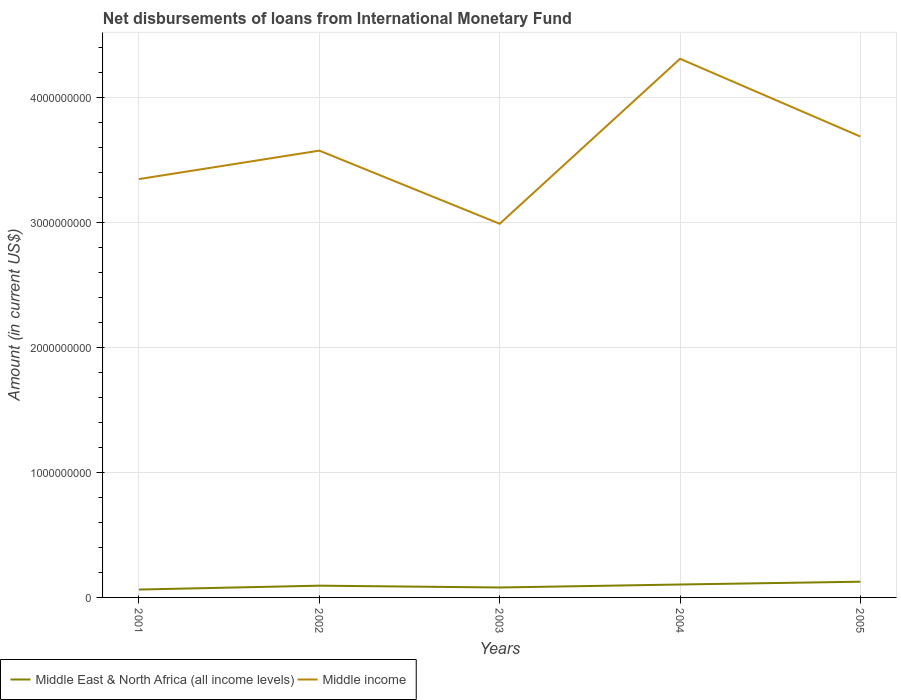How many different coloured lines are there?
Offer a terse response. 2. Across all years, what is the maximum amount of loans disbursed in Middle East & North Africa (all income levels)?
Offer a very short reply. 6.31e+07. What is the total amount of loans disbursed in Middle East & North Africa (all income levels) in the graph?
Keep it short and to the point. -2.40e+07. What is the difference between the highest and the second highest amount of loans disbursed in Middle income?
Offer a terse response. 1.32e+09. Is the amount of loans disbursed in Middle East & North Africa (all income levels) strictly greater than the amount of loans disbursed in Middle income over the years?
Your answer should be compact. Yes. How many lines are there?
Provide a short and direct response. 2. How many years are there in the graph?
Ensure brevity in your answer.  5. What is the difference between two consecutive major ticks on the Y-axis?
Offer a terse response. 1.00e+09. Does the graph contain any zero values?
Provide a short and direct response. No. Does the graph contain grids?
Provide a succinct answer. Yes. Where does the legend appear in the graph?
Provide a succinct answer. Bottom left. How many legend labels are there?
Provide a succinct answer. 2. What is the title of the graph?
Your answer should be compact. Net disbursements of loans from International Monetary Fund. Does "United Arab Emirates" appear as one of the legend labels in the graph?
Provide a succinct answer. No. What is the label or title of the X-axis?
Offer a terse response. Years. What is the label or title of the Y-axis?
Provide a succinct answer. Amount (in current US$). What is the Amount (in current US$) in Middle East & North Africa (all income levels) in 2001?
Your response must be concise. 6.31e+07. What is the Amount (in current US$) of Middle income in 2001?
Your response must be concise. 3.35e+09. What is the Amount (in current US$) in Middle East & North Africa (all income levels) in 2002?
Your response must be concise. 9.41e+07. What is the Amount (in current US$) in Middle income in 2002?
Your answer should be compact. 3.58e+09. What is the Amount (in current US$) of Middle East & North Africa (all income levels) in 2003?
Make the answer very short. 7.96e+07. What is the Amount (in current US$) of Middle income in 2003?
Give a very brief answer. 2.99e+09. What is the Amount (in current US$) of Middle East & North Africa (all income levels) in 2004?
Provide a succinct answer. 1.04e+08. What is the Amount (in current US$) in Middle income in 2004?
Ensure brevity in your answer.  4.31e+09. What is the Amount (in current US$) in Middle East & North Africa (all income levels) in 2005?
Your response must be concise. 1.26e+08. What is the Amount (in current US$) in Middle income in 2005?
Give a very brief answer. 3.69e+09. Across all years, what is the maximum Amount (in current US$) of Middle East & North Africa (all income levels)?
Ensure brevity in your answer.  1.26e+08. Across all years, what is the maximum Amount (in current US$) in Middle income?
Provide a short and direct response. 4.31e+09. Across all years, what is the minimum Amount (in current US$) in Middle East & North Africa (all income levels)?
Offer a very short reply. 6.31e+07. Across all years, what is the minimum Amount (in current US$) of Middle income?
Give a very brief answer. 2.99e+09. What is the total Amount (in current US$) in Middle East & North Africa (all income levels) in the graph?
Offer a very short reply. 4.66e+08. What is the total Amount (in current US$) in Middle income in the graph?
Provide a short and direct response. 1.79e+1. What is the difference between the Amount (in current US$) of Middle East & North Africa (all income levels) in 2001 and that in 2002?
Give a very brief answer. -3.10e+07. What is the difference between the Amount (in current US$) of Middle income in 2001 and that in 2002?
Offer a terse response. -2.28e+08. What is the difference between the Amount (in current US$) in Middle East & North Africa (all income levels) in 2001 and that in 2003?
Give a very brief answer. -1.65e+07. What is the difference between the Amount (in current US$) of Middle income in 2001 and that in 2003?
Give a very brief answer. 3.58e+08. What is the difference between the Amount (in current US$) of Middle East & North Africa (all income levels) in 2001 and that in 2004?
Give a very brief answer. -4.04e+07. What is the difference between the Amount (in current US$) in Middle income in 2001 and that in 2004?
Make the answer very short. -9.63e+08. What is the difference between the Amount (in current US$) in Middle East & North Africa (all income levels) in 2001 and that in 2005?
Give a very brief answer. -6.28e+07. What is the difference between the Amount (in current US$) in Middle income in 2001 and that in 2005?
Offer a terse response. -3.40e+08. What is the difference between the Amount (in current US$) of Middle East & North Africa (all income levels) in 2002 and that in 2003?
Ensure brevity in your answer.  1.46e+07. What is the difference between the Amount (in current US$) in Middle income in 2002 and that in 2003?
Keep it short and to the point. 5.86e+08. What is the difference between the Amount (in current US$) in Middle East & North Africa (all income levels) in 2002 and that in 2004?
Offer a terse response. -9.41e+06. What is the difference between the Amount (in current US$) in Middle income in 2002 and that in 2004?
Offer a terse response. -7.35e+08. What is the difference between the Amount (in current US$) in Middle East & North Africa (all income levels) in 2002 and that in 2005?
Provide a succinct answer. -3.17e+07. What is the difference between the Amount (in current US$) of Middle income in 2002 and that in 2005?
Give a very brief answer. -1.13e+08. What is the difference between the Amount (in current US$) in Middle East & North Africa (all income levels) in 2003 and that in 2004?
Provide a succinct answer. -2.40e+07. What is the difference between the Amount (in current US$) in Middle income in 2003 and that in 2004?
Your answer should be very brief. -1.32e+09. What is the difference between the Amount (in current US$) of Middle East & North Africa (all income levels) in 2003 and that in 2005?
Provide a succinct answer. -4.63e+07. What is the difference between the Amount (in current US$) in Middle income in 2003 and that in 2005?
Offer a very short reply. -6.98e+08. What is the difference between the Amount (in current US$) of Middle East & North Africa (all income levels) in 2004 and that in 2005?
Keep it short and to the point. -2.23e+07. What is the difference between the Amount (in current US$) of Middle income in 2004 and that in 2005?
Offer a terse response. 6.23e+08. What is the difference between the Amount (in current US$) of Middle East & North Africa (all income levels) in 2001 and the Amount (in current US$) of Middle income in 2002?
Your response must be concise. -3.51e+09. What is the difference between the Amount (in current US$) in Middle East & North Africa (all income levels) in 2001 and the Amount (in current US$) in Middle income in 2003?
Ensure brevity in your answer.  -2.93e+09. What is the difference between the Amount (in current US$) of Middle East & North Africa (all income levels) in 2001 and the Amount (in current US$) of Middle income in 2004?
Offer a very short reply. -4.25e+09. What is the difference between the Amount (in current US$) in Middle East & North Africa (all income levels) in 2001 and the Amount (in current US$) in Middle income in 2005?
Offer a very short reply. -3.63e+09. What is the difference between the Amount (in current US$) in Middle East & North Africa (all income levels) in 2002 and the Amount (in current US$) in Middle income in 2003?
Provide a short and direct response. -2.90e+09. What is the difference between the Amount (in current US$) of Middle East & North Africa (all income levels) in 2002 and the Amount (in current US$) of Middle income in 2004?
Give a very brief answer. -4.22e+09. What is the difference between the Amount (in current US$) of Middle East & North Africa (all income levels) in 2002 and the Amount (in current US$) of Middle income in 2005?
Offer a very short reply. -3.60e+09. What is the difference between the Amount (in current US$) of Middle East & North Africa (all income levels) in 2003 and the Amount (in current US$) of Middle income in 2004?
Offer a terse response. -4.23e+09. What is the difference between the Amount (in current US$) of Middle East & North Africa (all income levels) in 2003 and the Amount (in current US$) of Middle income in 2005?
Make the answer very short. -3.61e+09. What is the difference between the Amount (in current US$) of Middle East & North Africa (all income levels) in 2004 and the Amount (in current US$) of Middle income in 2005?
Make the answer very short. -3.59e+09. What is the average Amount (in current US$) of Middle East & North Africa (all income levels) per year?
Your response must be concise. 9.32e+07. What is the average Amount (in current US$) of Middle income per year?
Your response must be concise. 3.58e+09. In the year 2001, what is the difference between the Amount (in current US$) in Middle East & North Africa (all income levels) and Amount (in current US$) in Middle income?
Keep it short and to the point. -3.29e+09. In the year 2002, what is the difference between the Amount (in current US$) of Middle East & North Africa (all income levels) and Amount (in current US$) of Middle income?
Your answer should be very brief. -3.48e+09. In the year 2003, what is the difference between the Amount (in current US$) of Middle East & North Africa (all income levels) and Amount (in current US$) of Middle income?
Give a very brief answer. -2.91e+09. In the year 2004, what is the difference between the Amount (in current US$) of Middle East & North Africa (all income levels) and Amount (in current US$) of Middle income?
Make the answer very short. -4.21e+09. In the year 2005, what is the difference between the Amount (in current US$) of Middle East & North Africa (all income levels) and Amount (in current US$) of Middle income?
Ensure brevity in your answer.  -3.56e+09. What is the ratio of the Amount (in current US$) of Middle East & North Africa (all income levels) in 2001 to that in 2002?
Offer a very short reply. 0.67. What is the ratio of the Amount (in current US$) of Middle income in 2001 to that in 2002?
Your answer should be very brief. 0.94. What is the ratio of the Amount (in current US$) in Middle East & North Africa (all income levels) in 2001 to that in 2003?
Provide a succinct answer. 0.79. What is the ratio of the Amount (in current US$) of Middle income in 2001 to that in 2003?
Give a very brief answer. 1.12. What is the ratio of the Amount (in current US$) of Middle East & North Africa (all income levels) in 2001 to that in 2004?
Keep it short and to the point. 0.61. What is the ratio of the Amount (in current US$) of Middle income in 2001 to that in 2004?
Provide a short and direct response. 0.78. What is the ratio of the Amount (in current US$) in Middle East & North Africa (all income levels) in 2001 to that in 2005?
Keep it short and to the point. 0.5. What is the ratio of the Amount (in current US$) of Middle income in 2001 to that in 2005?
Provide a short and direct response. 0.91. What is the ratio of the Amount (in current US$) of Middle East & North Africa (all income levels) in 2002 to that in 2003?
Offer a terse response. 1.18. What is the ratio of the Amount (in current US$) of Middle income in 2002 to that in 2003?
Your response must be concise. 1.2. What is the ratio of the Amount (in current US$) of Middle income in 2002 to that in 2004?
Your response must be concise. 0.83. What is the ratio of the Amount (in current US$) in Middle East & North Africa (all income levels) in 2002 to that in 2005?
Give a very brief answer. 0.75. What is the ratio of the Amount (in current US$) in Middle income in 2002 to that in 2005?
Your answer should be compact. 0.97. What is the ratio of the Amount (in current US$) in Middle East & North Africa (all income levels) in 2003 to that in 2004?
Provide a short and direct response. 0.77. What is the ratio of the Amount (in current US$) in Middle income in 2003 to that in 2004?
Give a very brief answer. 0.69. What is the ratio of the Amount (in current US$) in Middle East & North Africa (all income levels) in 2003 to that in 2005?
Make the answer very short. 0.63. What is the ratio of the Amount (in current US$) of Middle income in 2003 to that in 2005?
Ensure brevity in your answer.  0.81. What is the ratio of the Amount (in current US$) of Middle East & North Africa (all income levels) in 2004 to that in 2005?
Provide a short and direct response. 0.82. What is the ratio of the Amount (in current US$) in Middle income in 2004 to that in 2005?
Ensure brevity in your answer.  1.17. What is the difference between the highest and the second highest Amount (in current US$) of Middle East & North Africa (all income levels)?
Your response must be concise. 2.23e+07. What is the difference between the highest and the second highest Amount (in current US$) of Middle income?
Offer a very short reply. 6.23e+08. What is the difference between the highest and the lowest Amount (in current US$) of Middle East & North Africa (all income levels)?
Ensure brevity in your answer.  6.28e+07. What is the difference between the highest and the lowest Amount (in current US$) of Middle income?
Provide a short and direct response. 1.32e+09. 